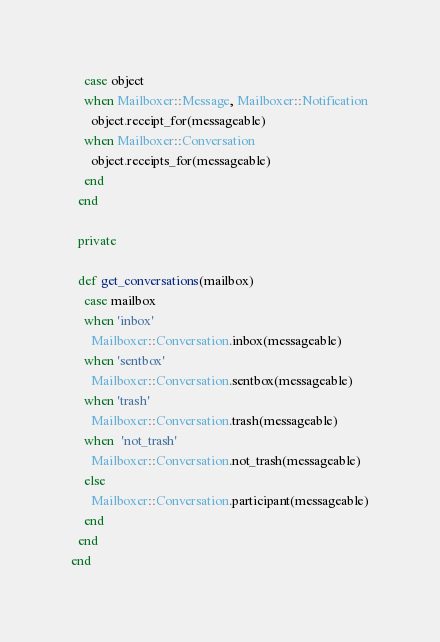Convert code to text. <code><loc_0><loc_0><loc_500><loc_500><_Ruby_>    case object
    when Mailboxer::Message, Mailboxer::Notification
      object.receipt_for(messageable)
    when Mailboxer::Conversation
      object.receipts_for(messageable)
    end
  end

  private

  def get_conversations(mailbox)
    case mailbox
    when 'inbox'
      Mailboxer::Conversation.inbox(messageable)
    when 'sentbox'
      Mailboxer::Conversation.sentbox(messageable)
    when 'trash'
      Mailboxer::Conversation.trash(messageable)
    when  'not_trash'
      Mailboxer::Conversation.not_trash(messageable)
    else
      Mailboxer::Conversation.participant(messageable)
    end
  end
end
</code> 